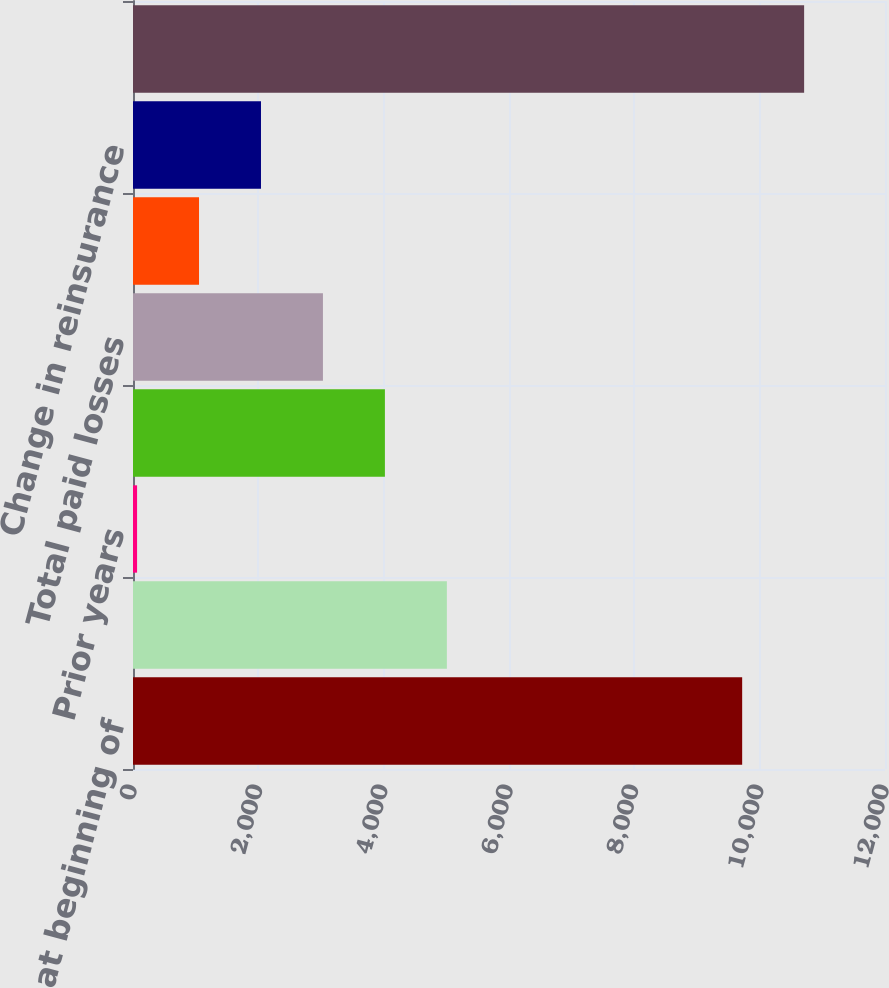Convert chart. <chart><loc_0><loc_0><loc_500><loc_500><bar_chart><fcel>Gross reserves at beginning of<fcel>Current year<fcel>Prior years<fcel>Total incurred losses<fcel>Total paid losses<fcel>Foreign exchange/translation<fcel>Change in reinsurance<fcel>Gross reserves at end of<nl><fcel>9720.8<fcel>5008.4<fcel>65<fcel>4019.72<fcel>3031.04<fcel>1053.68<fcel>2042.36<fcel>10709.5<nl></chart> 